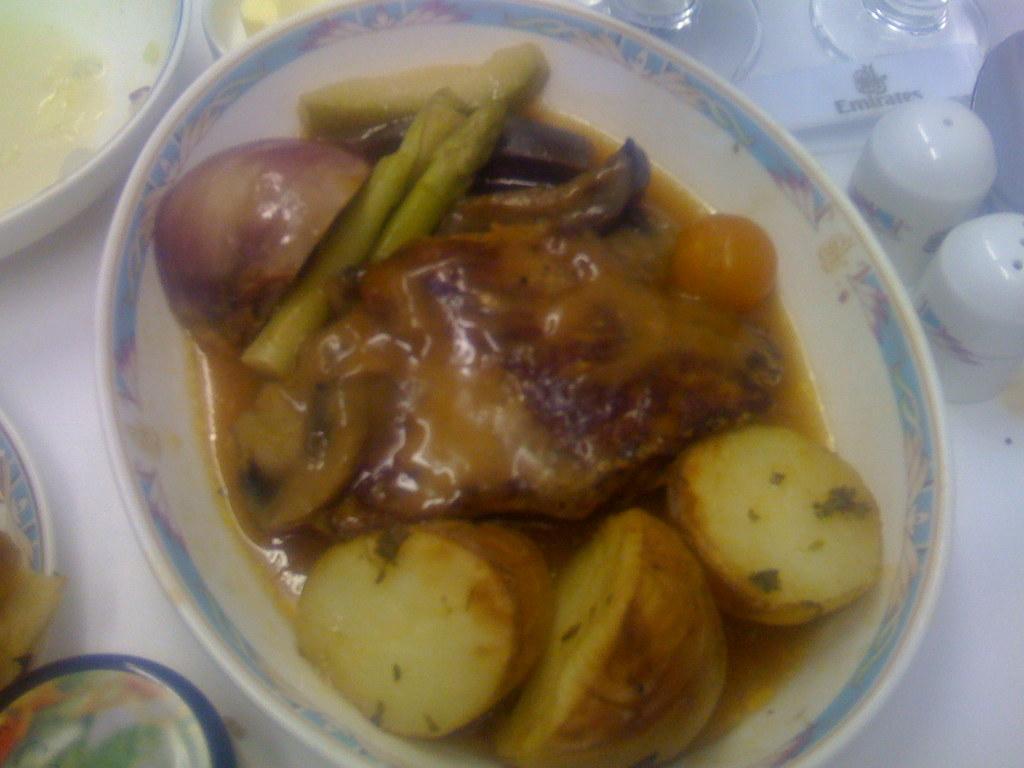Can you describe this image briefly? In this image there is a plate. In the plate there are potato pieces,onion piece, carrot slices and some food stuff. On the right side top there are two glasses. Beside the glasses there are two small jars. On the left side top there is a plate in which there is soup. On the left side bottom there are two other plates. 